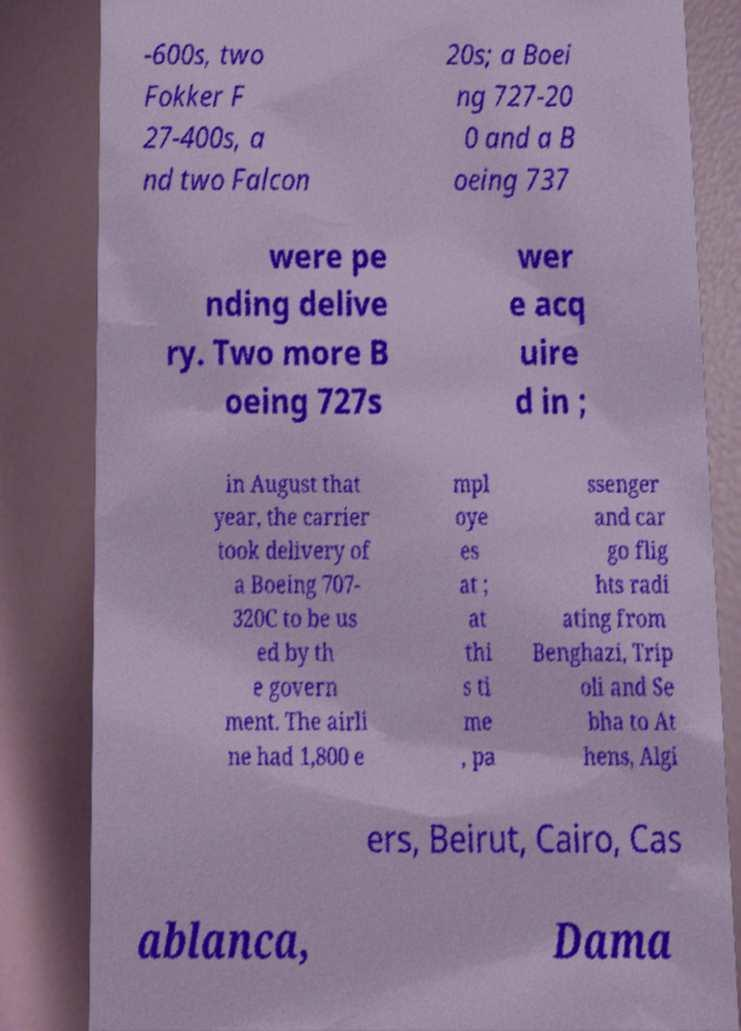Can you read and provide the text displayed in the image?This photo seems to have some interesting text. Can you extract and type it out for me? -600s, two Fokker F 27-400s, a nd two Falcon 20s; a Boei ng 727-20 0 and a B oeing 737 were pe nding delive ry. Two more B oeing 727s wer e acq uire d in ; in August that year, the carrier took delivery of a Boeing 707- 320C to be us ed by th e govern ment. The airli ne had 1,800 e mpl oye es at ; at thi s ti me , pa ssenger and car go flig hts radi ating from Benghazi, Trip oli and Se bha to At hens, Algi ers, Beirut, Cairo, Cas ablanca, Dama 